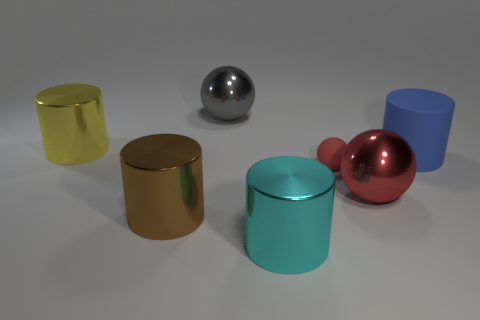Are there any reflective surfaces visible? Yes, the silver and red spheres, as well as the gold and cyan cylinders, have reflective surfaces that display the environment around them, along with highlights and shadows that enhance their three-dimensional appearance. 